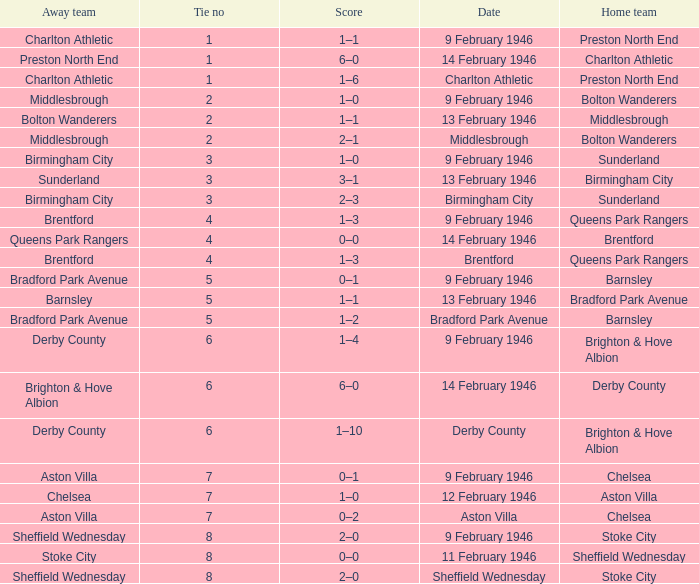What is the average Tie no when the date is Birmingham City? 3.0. 